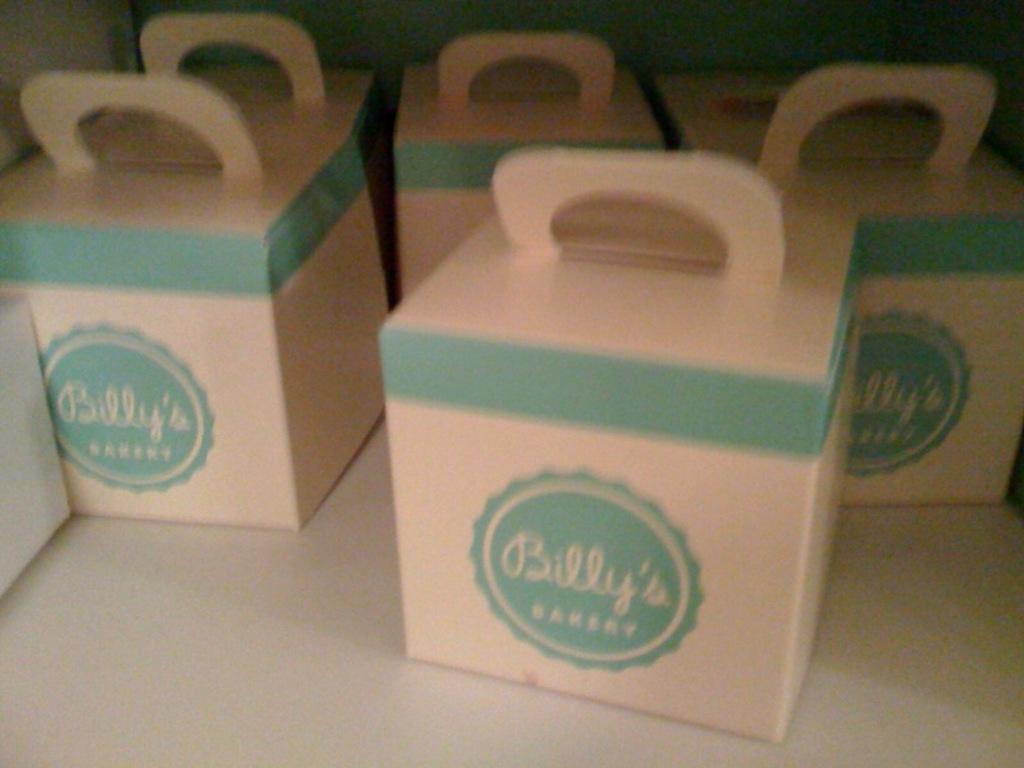What is the name of this bakery?
Make the answer very short. Billy's. What type of store is this from?
Offer a very short reply. Bakery. 